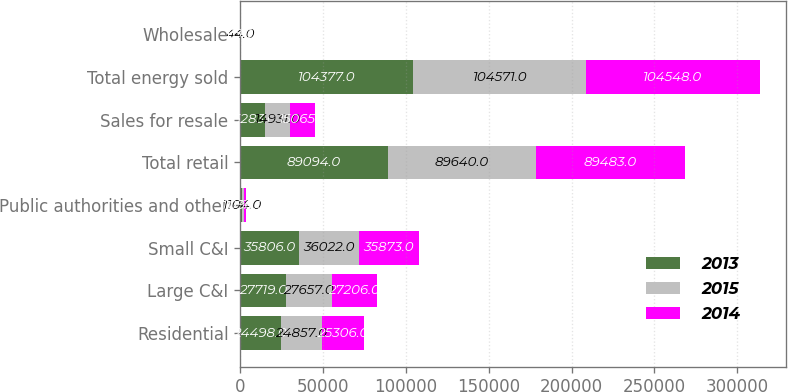<chart> <loc_0><loc_0><loc_500><loc_500><stacked_bar_chart><ecel><fcel>Residential<fcel>Large C&I<fcel>Small C&I<fcel>Public authorities and other<fcel>Total retail<fcel>Sales for resale<fcel>Total energy sold<fcel>Wholesale<nl><fcel>2013<fcel>24498<fcel>27719<fcel>35806<fcel>1071<fcel>89094<fcel>15283<fcel>104377<fcel>47<nl><fcel>2015<fcel>24857<fcel>27657<fcel>36022<fcel>1104<fcel>89640<fcel>14931<fcel>104571<fcel>44<nl><fcel>2014<fcel>25306<fcel>27206<fcel>35873<fcel>1098<fcel>89483<fcel>15065<fcel>104548<fcel>65<nl></chart> 